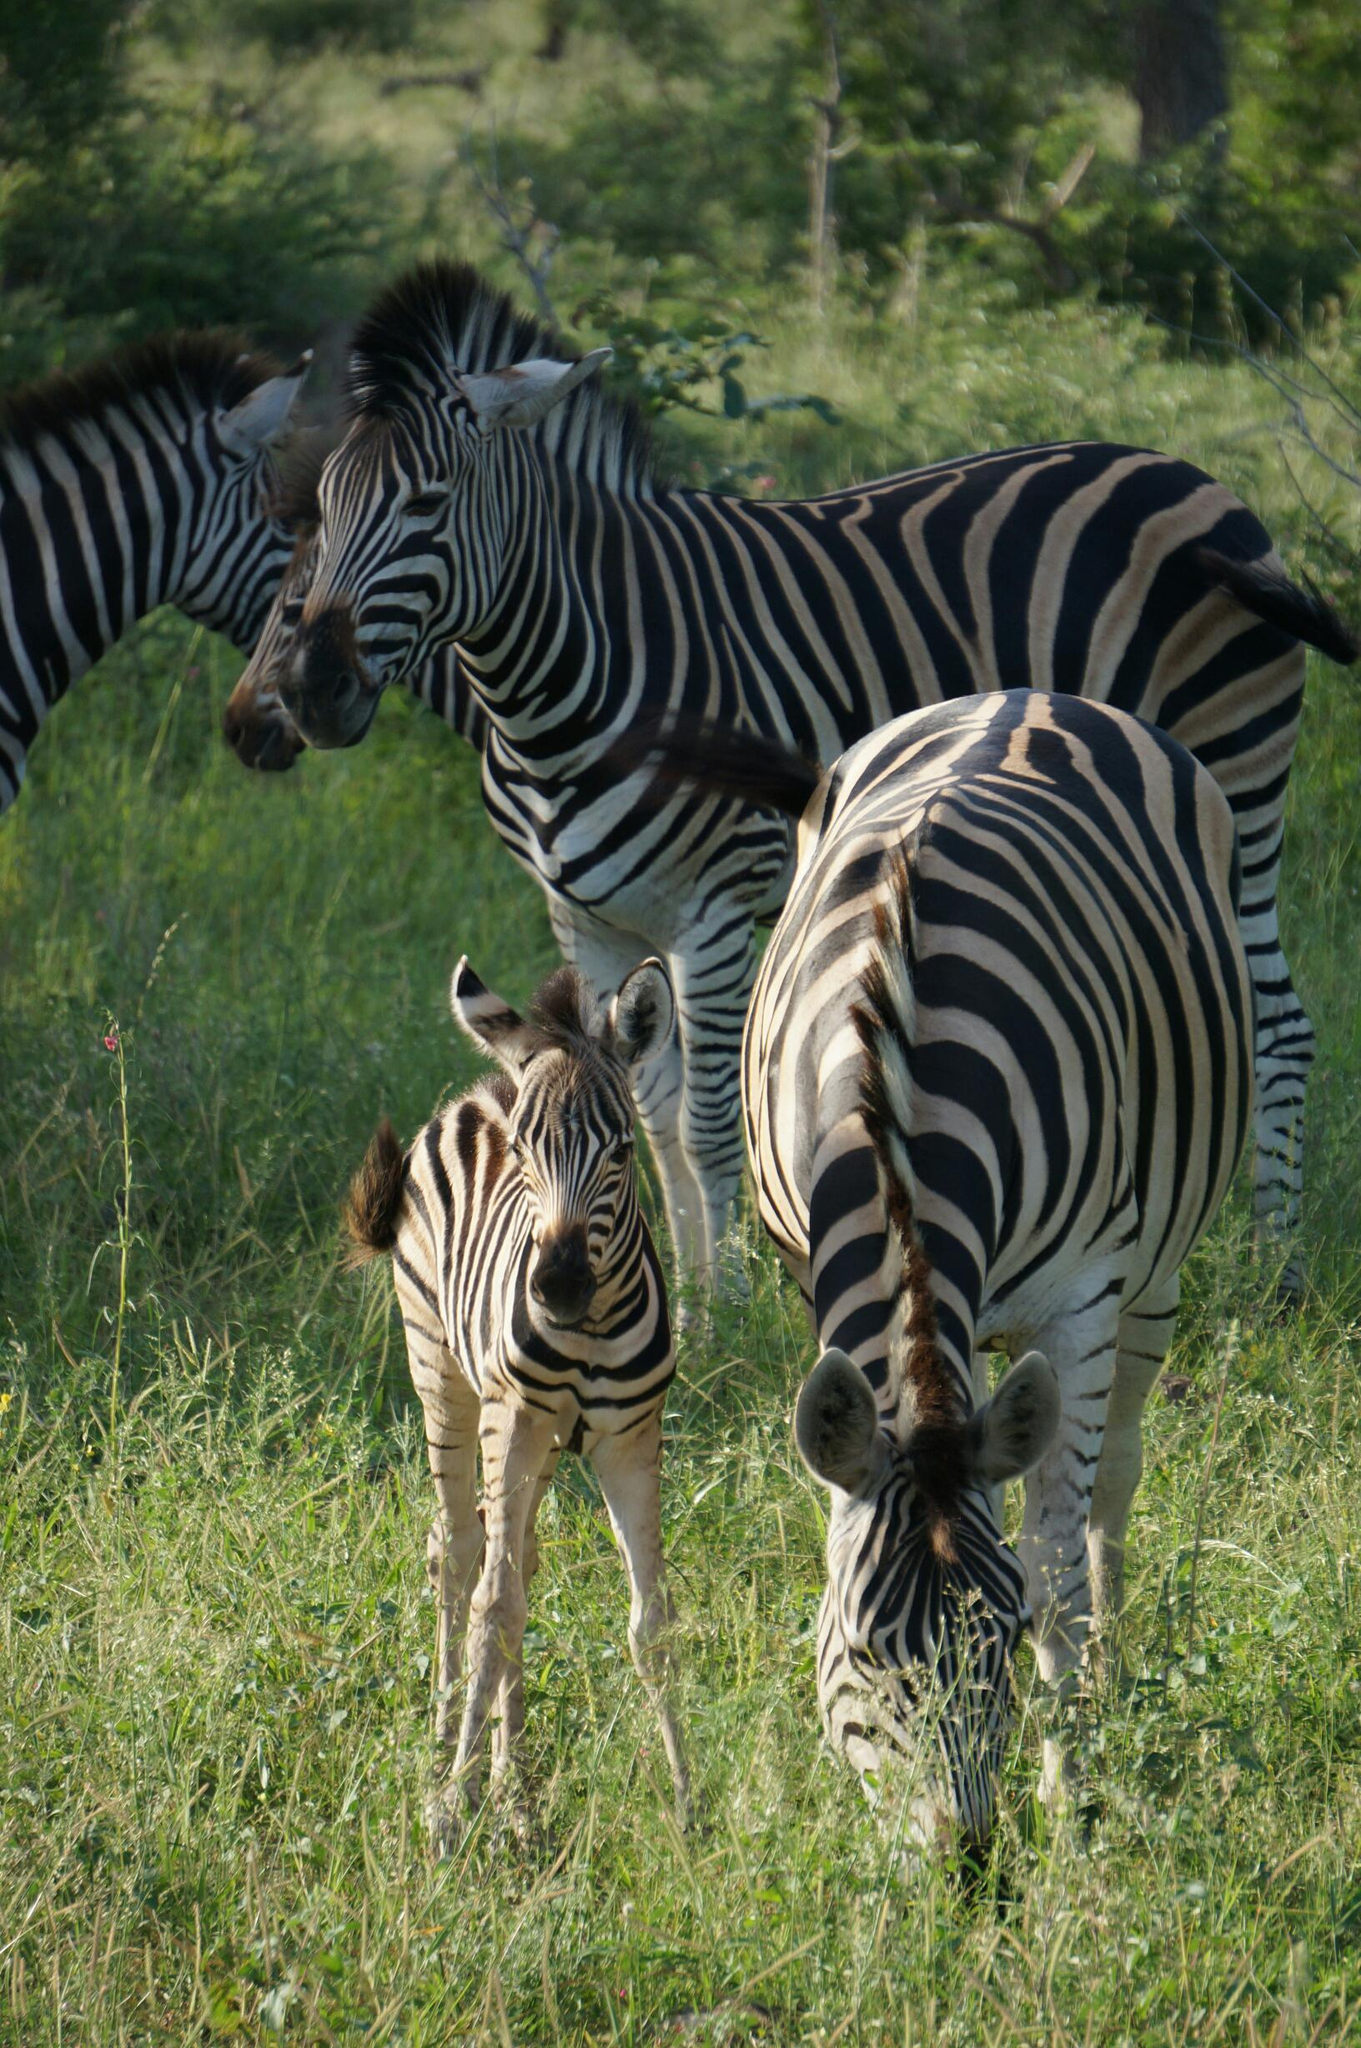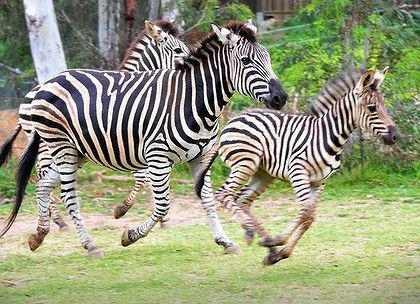The first image is the image on the left, the second image is the image on the right. Assess this claim about the two images: "No more than one zebra has its head down in the image on the right.". Correct or not? Answer yes or no. No. The first image is the image on the left, the second image is the image on the right. Assess this claim about the two images: "In the foreground of the lefthand image, two zebras stand with bodies turned toward each other and faces turned to the camera.". Correct or not? Answer yes or no. No. 